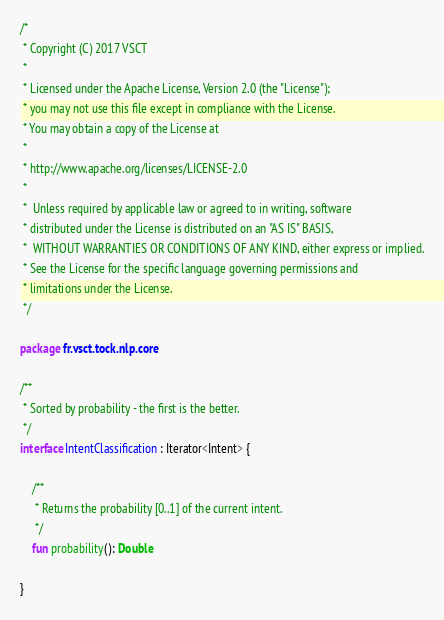<code> <loc_0><loc_0><loc_500><loc_500><_Kotlin_>/*
 * Copyright (C) 2017 VSCT
 *
 * Licensed under the Apache License, Version 2.0 (the "License");
 * you may not use this file except in compliance with the License.
 * You may obtain a copy of the License at
 *
 * http://www.apache.org/licenses/LICENSE-2.0
 *
 *  Unless required by applicable law or agreed to in writing, software
 * distributed under the License is distributed on an "AS IS" BASIS,
 *  WITHOUT WARRANTIES OR CONDITIONS OF ANY KIND, either express or implied.
 * See the License for the specific language governing permissions and
 * limitations under the License.
 */

package fr.vsct.tock.nlp.core

/**
 * Sorted by probability - the first is the better.
 */
interface IntentClassification : Iterator<Intent> {

    /**
     * Returns the probability [0..1] of the current intent.
     */
    fun probability(): Double

}</code> 